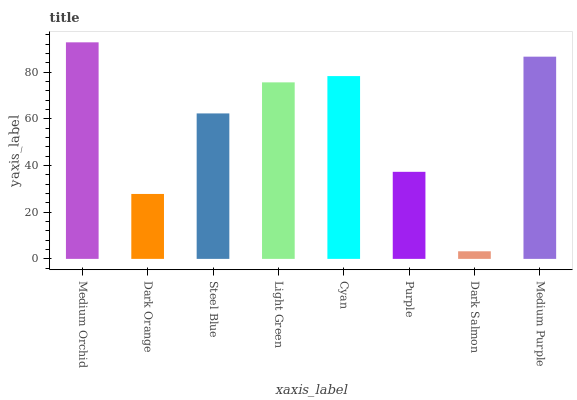Is Dark Orange the minimum?
Answer yes or no. No. Is Dark Orange the maximum?
Answer yes or no. No. Is Medium Orchid greater than Dark Orange?
Answer yes or no. Yes. Is Dark Orange less than Medium Orchid?
Answer yes or no. Yes. Is Dark Orange greater than Medium Orchid?
Answer yes or no. No. Is Medium Orchid less than Dark Orange?
Answer yes or no. No. Is Light Green the high median?
Answer yes or no. Yes. Is Steel Blue the low median?
Answer yes or no. Yes. Is Dark Orange the high median?
Answer yes or no. No. Is Medium Orchid the low median?
Answer yes or no. No. 